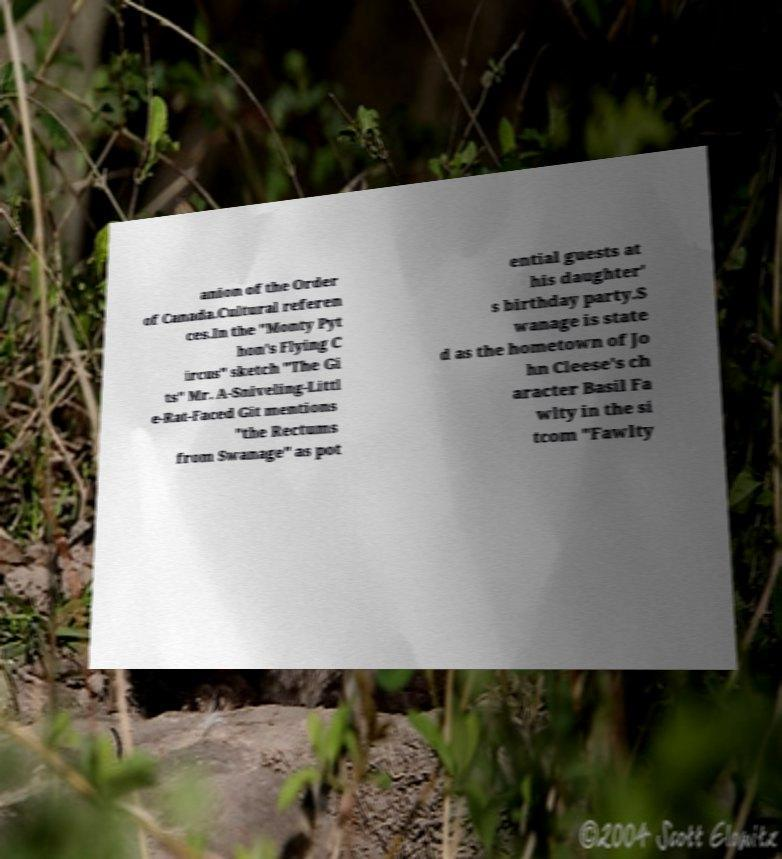Can you accurately transcribe the text from the provided image for me? anion of the Order of Canada.Cultural referen ces.In the "Monty Pyt hon's Flying C ircus" sketch "The Gi ts" Mr. A-Sniveling-Littl e-Rat-Faced Git mentions "the Rectums from Swanage" as pot ential guests at his daughter' s birthday party.S wanage is state d as the hometown of Jo hn Cleese's ch aracter Basil Fa wlty in the si tcom "Fawlty 